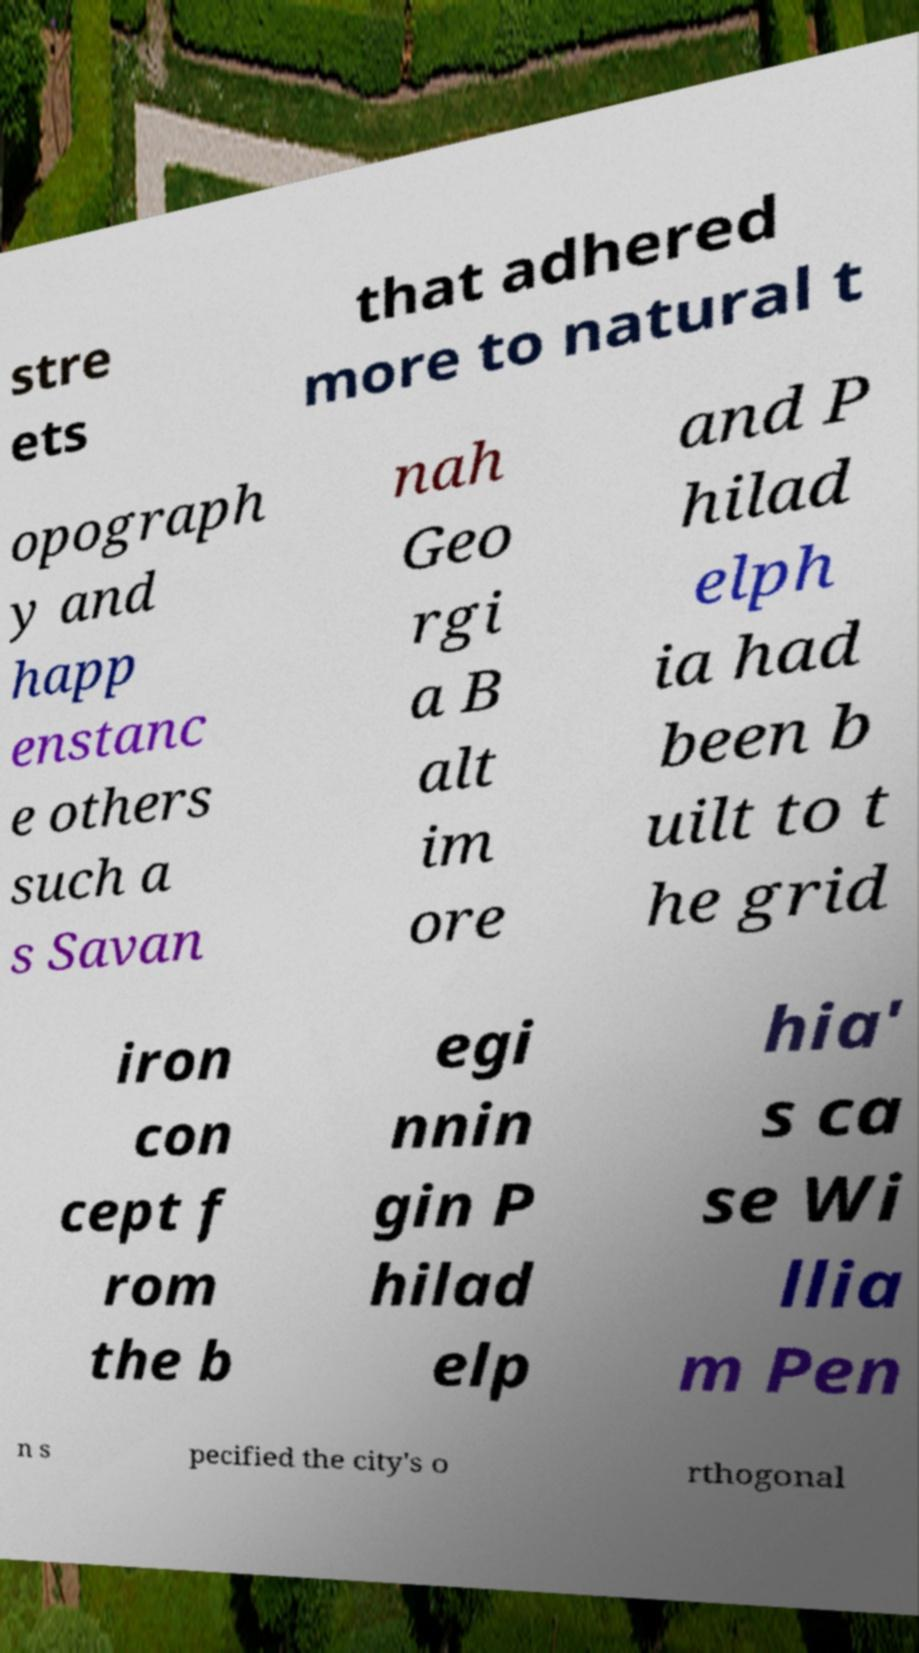For documentation purposes, I need the text within this image transcribed. Could you provide that? stre ets that adhered more to natural t opograph y and happ enstanc e others such a s Savan nah Geo rgi a B alt im ore and P hilad elph ia had been b uilt to t he grid iron con cept f rom the b egi nnin gin P hilad elp hia' s ca se Wi llia m Pen n s pecified the city's o rthogonal 